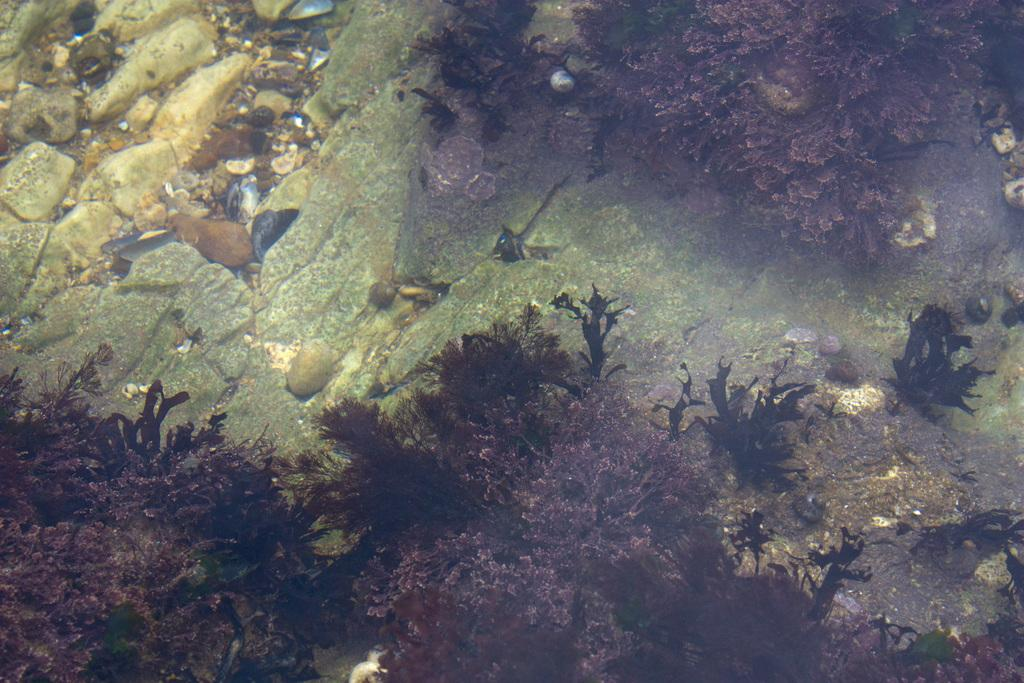What type of living organisms can be seen in the image? Plants can be seen in the image. What other objects are present in the image? There are stones in the image. Where are the stones located? The stones are on a rock surface. What is the rock surface situated in? The rock surface is under water. What is the opinion of the kittens about the plants in the image? There are no kittens present in the image, so their opinion cannot be determined. 